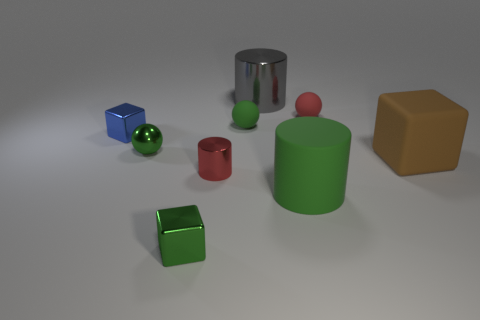Add 1 matte spheres. How many objects exist? 10 Subtract all cylinders. How many objects are left? 6 Subtract 0 purple cylinders. How many objects are left? 9 Subtract all large green blocks. Subtract all blue metallic blocks. How many objects are left? 8 Add 3 matte things. How many matte things are left? 7 Add 2 small metallic cubes. How many small metallic cubes exist? 4 